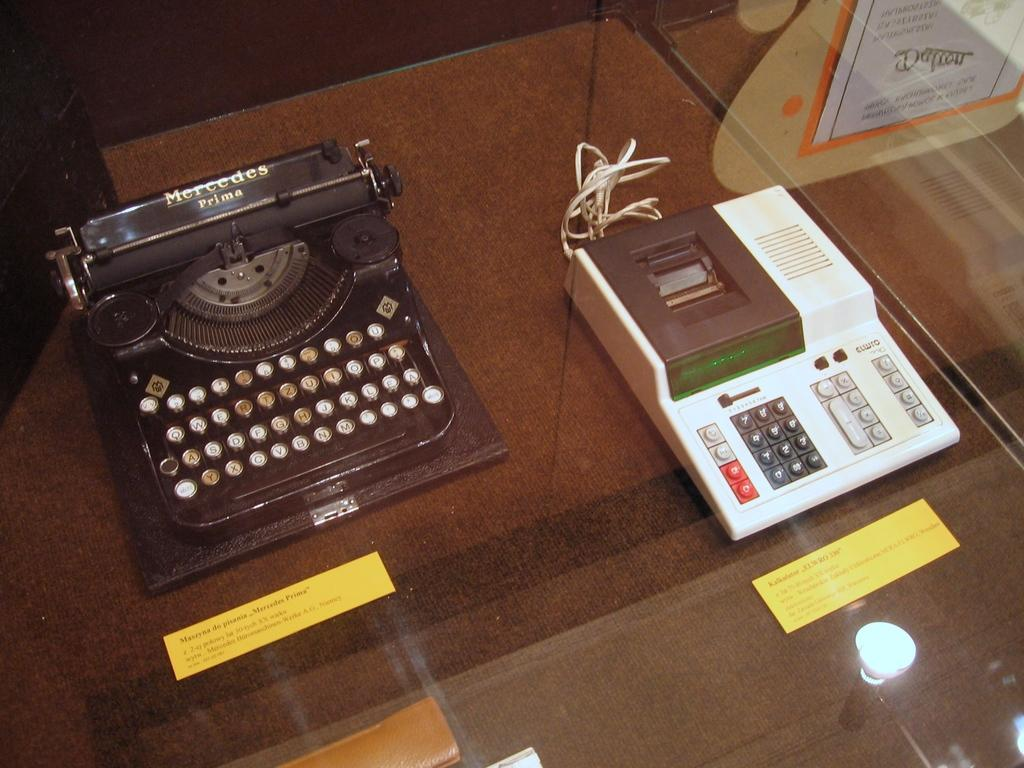<image>
Present a compact description of the photo's key features. A Mercedes prima typewriter is displayed on a glass table next to a EL WRO 330 calculator. 